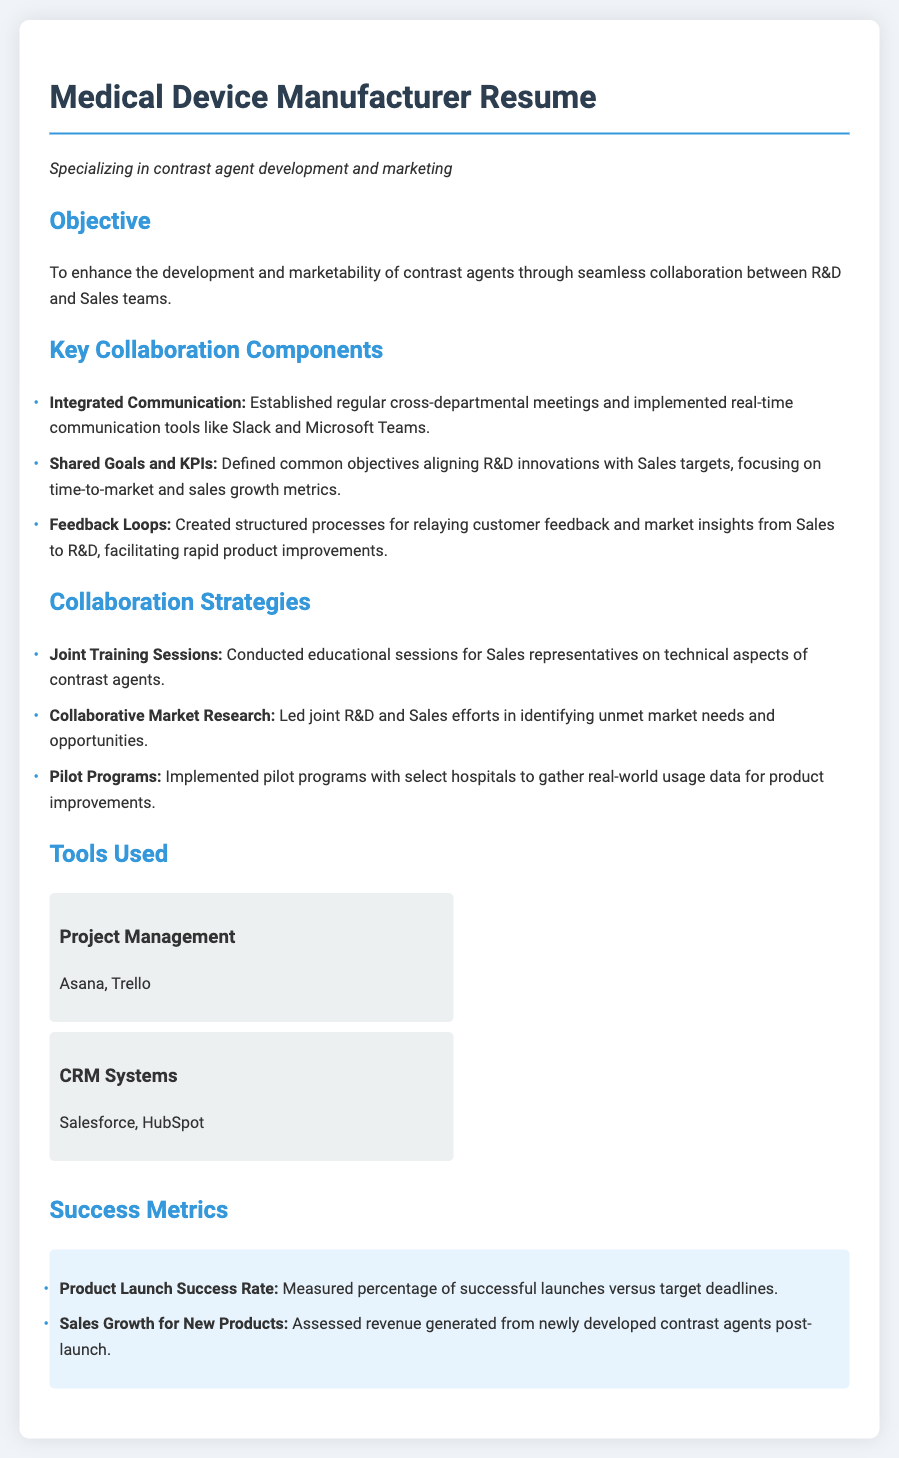what is the objective stated in the resume? The objective is to enhance the development and marketability of contrast agents through seamless collaboration between R&D and Sales teams.
Answer: enhance the development and marketability of contrast agents through seamless collaboration between R&D and Sales teams what communication tools are mentioned for integrated communication? The document lists real-time communication tools like Slack and Microsoft Teams for integrated communication.
Answer: Slack and Microsoft Teams what are the key components defined for collaboration? The key collaboration components outlined in the document include integrated communication, shared goals and KPIs, and feedback loops.
Answer: integrated communication, shared goals and KPIs, feedback loops how are success metrics related to product launches for new products measured? The document states that success metrics are measured by the percentage of successful launches versus target deadlines and revenue from newly developed contrast agents post-launch.
Answer: percentage of successful launches versus target deadlines; revenue generated from newly developed contrast agents post-launch which tools are used for project management in collaboration? The resume mentions Asana and Trello as project management tools used in collaboration.
Answer: Asana, Trello what type of sessions were conducted for Sales representatives? The resume indicates that joint training sessions were conducted for Sales representatives on technical aspects of contrast agents.
Answer: joint training sessions 